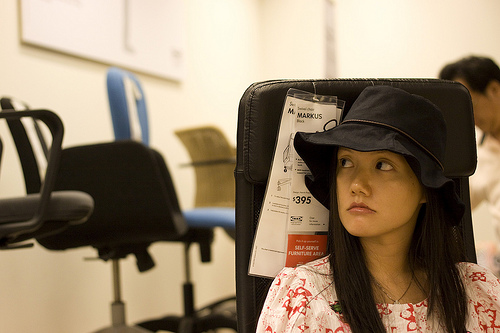<image>
Is the girl in front of the office chair? Yes. The girl is positioned in front of the office chair, appearing closer to the camera viewpoint. 